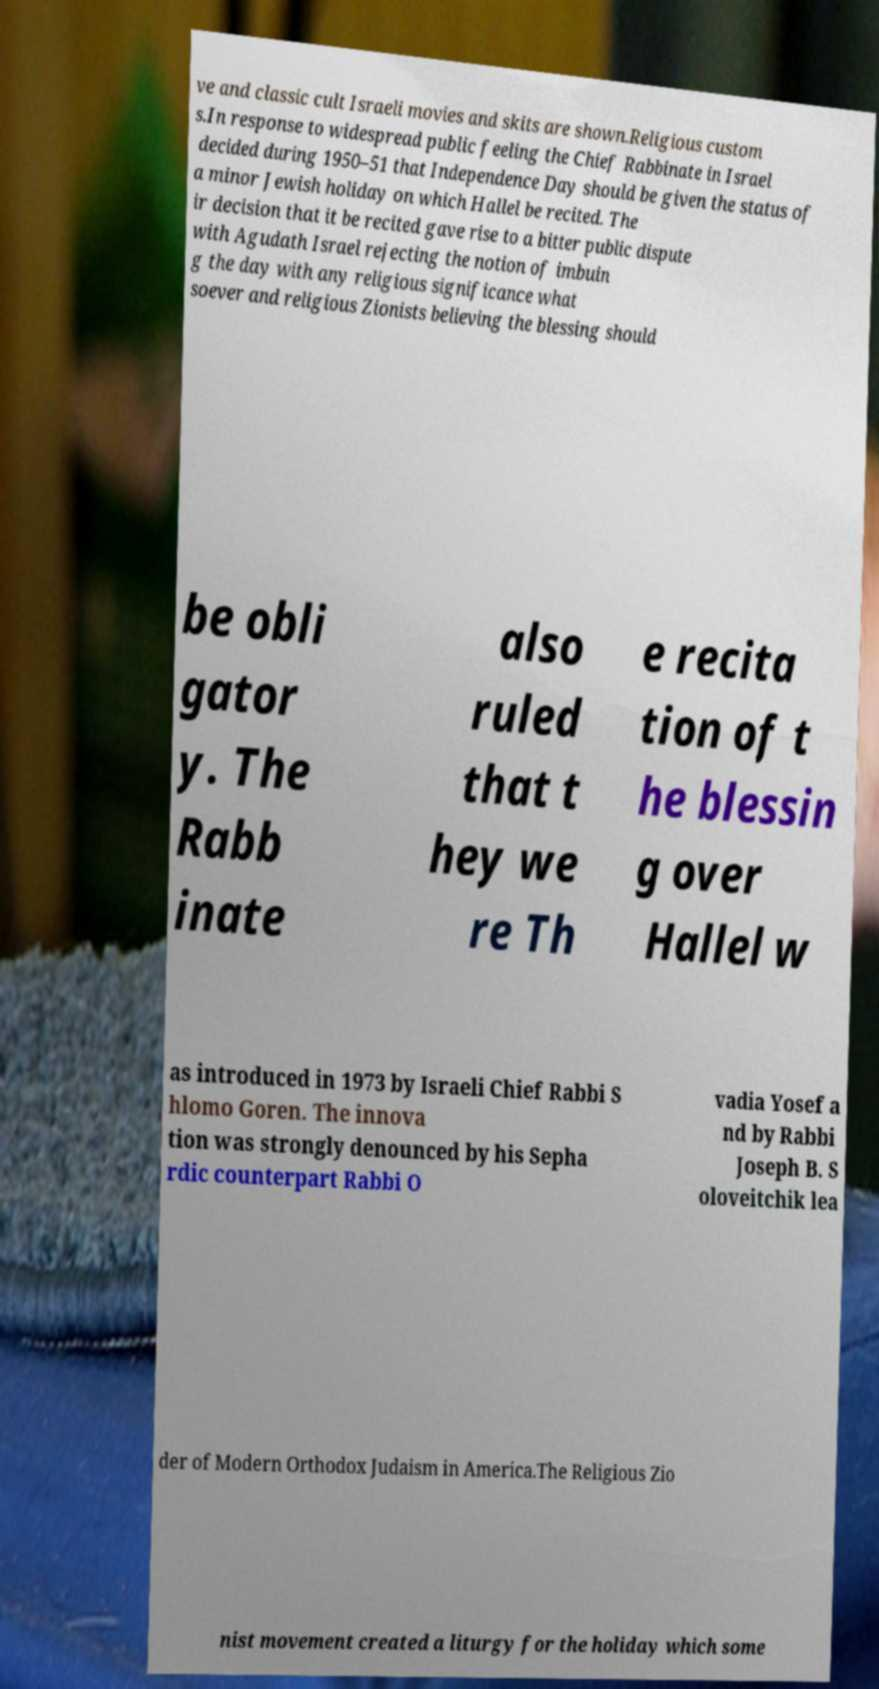Could you assist in decoding the text presented in this image and type it out clearly? ve and classic cult Israeli movies and skits are shown.Religious custom s.In response to widespread public feeling the Chief Rabbinate in Israel decided during 1950–51 that Independence Day should be given the status of a minor Jewish holiday on which Hallel be recited. The ir decision that it be recited gave rise to a bitter public dispute with Agudath Israel rejecting the notion of imbuin g the day with any religious significance what soever and religious Zionists believing the blessing should be obli gator y. The Rabb inate also ruled that t hey we re Th e recita tion of t he blessin g over Hallel w as introduced in 1973 by Israeli Chief Rabbi S hlomo Goren. The innova tion was strongly denounced by his Sepha rdic counterpart Rabbi O vadia Yosef a nd by Rabbi Joseph B. S oloveitchik lea der of Modern Orthodox Judaism in America.The Religious Zio nist movement created a liturgy for the holiday which some 